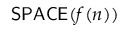Convert formula to latex. <formula><loc_0><loc_0><loc_500><loc_500>{ S P A C E } ( f ( n ) )</formula> 